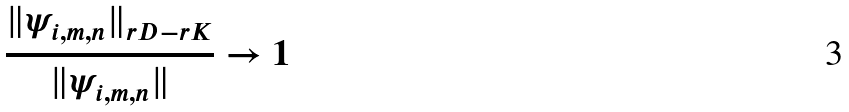<formula> <loc_0><loc_0><loc_500><loc_500>\frac { \| \psi _ { i , m , n } \| _ { r D - r K } } { \| \psi _ { i , m , n } \| } \to 1</formula> 